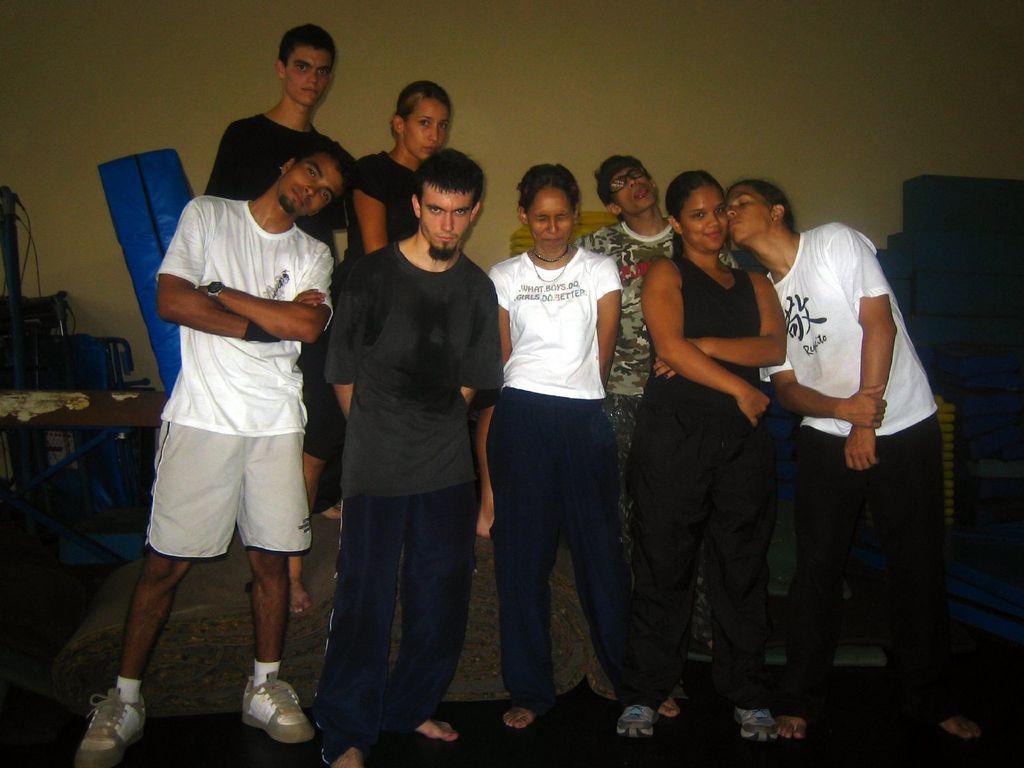Can you describe this image briefly? In the picture I can see a group of people standing on the floor and looks like they are posing for a photo. I can see a table on the floor on the left side. In the background, I can see the wall. 